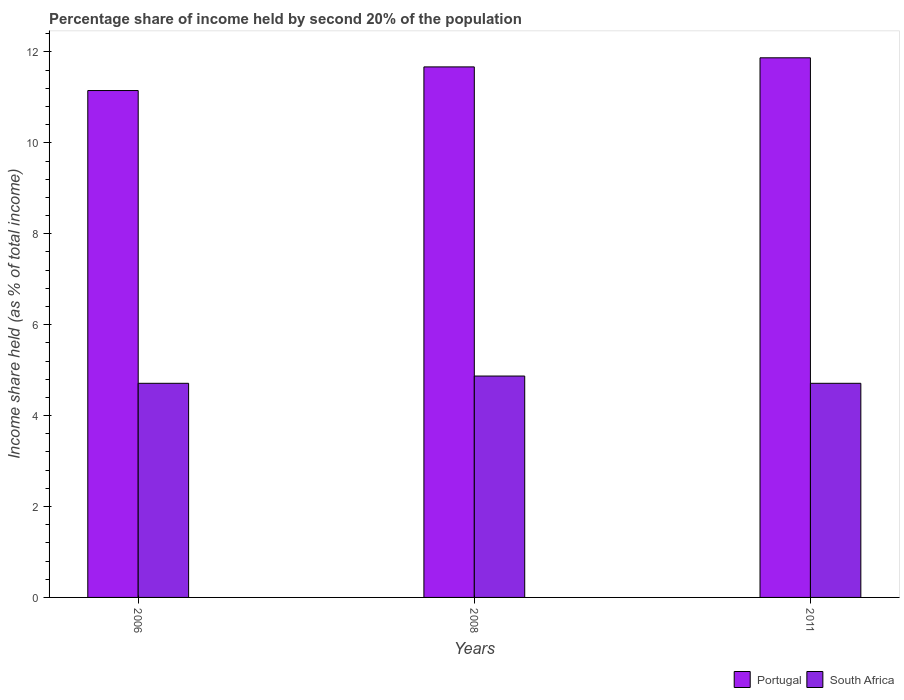How many different coloured bars are there?
Keep it short and to the point. 2. How many groups of bars are there?
Your response must be concise. 3. Are the number of bars per tick equal to the number of legend labels?
Your response must be concise. Yes. How many bars are there on the 3rd tick from the right?
Give a very brief answer. 2. In how many cases, is the number of bars for a given year not equal to the number of legend labels?
Offer a terse response. 0. What is the share of income held by second 20% of the population in South Africa in 2008?
Make the answer very short. 4.87. Across all years, what is the maximum share of income held by second 20% of the population in Portugal?
Your answer should be compact. 11.87. Across all years, what is the minimum share of income held by second 20% of the population in Portugal?
Give a very brief answer. 11.15. In which year was the share of income held by second 20% of the population in South Africa maximum?
Provide a succinct answer. 2008. What is the total share of income held by second 20% of the population in South Africa in the graph?
Offer a terse response. 14.29. What is the difference between the share of income held by second 20% of the population in South Africa in 2006 and that in 2008?
Give a very brief answer. -0.16. What is the difference between the share of income held by second 20% of the population in South Africa in 2008 and the share of income held by second 20% of the population in Portugal in 2011?
Provide a short and direct response. -7. What is the average share of income held by second 20% of the population in Portugal per year?
Offer a terse response. 11.56. In the year 2006, what is the difference between the share of income held by second 20% of the population in Portugal and share of income held by second 20% of the population in South Africa?
Your response must be concise. 6.44. In how many years, is the share of income held by second 20% of the population in Portugal greater than 3.2 %?
Ensure brevity in your answer.  3. What is the ratio of the share of income held by second 20% of the population in South Africa in 2006 to that in 2011?
Provide a short and direct response. 1. Is the share of income held by second 20% of the population in South Africa in 2008 less than that in 2011?
Your answer should be very brief. No. Is the difference between the share of income held by second 20% of the population in Portugal in 2006 and 2011 greater than the difference between the share of income held by second 20% of the population in South Africa in 2006 and 2011?
Give a very brief answer. No. What is the difference between the highest and the second highest share of income held by second 20% of the population in Portugal?
Offer a terse response. 0.2. What is the difference between the highest and the lowest share of income held by second 20% of the population in Portugal?
Give a very brief answer. 0.72. In how many years, is the share of income held by second 20% of the population in South Africa greater than the average share of income held by second 20% of the population in South Africa taken over all years?
Provide a succinct answer. 1. What does the 1st bar from the right in 2006 represents?
Provide a short and direct response. South Africa. Are all the bars in the graph horizontal?
Provide a short and direct response. No. Are the values on the major ticks of Y-axis written in scientific E-notation?
Your answer should be very brief. No. How many legend labels are there?
Your answer should be very brief. 2. How are the legend labels stacked?
Your answer should be compact. Horizontal. What is the title of the graph?
Make the answer very short. Percentage share of income held by second 20% of the population. What is the label or title of the X-axis?
Provide a short and direct response. Years. What is the label or title of the Y-axis?
Your answer should be compact. Income share held (as % of total income). What is the Income share held (as % of total income) in Portugal in 2006?
Give a very brief answer. 11.15. What is the Income share held (as % of total income) of South Africa in 2006?
Offer a very short reply. 4.71. What is the Income share held (as % of total income) of Portugal in 2008?
Ensure brevity in your answer.  11.67. What is the Income share held (as % of total income) of South Africa in 2008?
Make the answer very short. 4.87. What is the Income share held (as % of total income) in Portugal in 2011?
Offer a very short reply. 11.87. What is the Income share held (as % of total income) in South Africa in 2011?
Give a very brief answer. 4.71. Across all years, what is the maximum Income share held (as % of total income) of Portugal?
Your answer should be compact. 11.87. Across all years, what is the maximum Income share held (as % of total income) of South Africa?
Provide a succinct answer. 4.87. Across all years, what is the minimum Income share held (as % of total income) of Portugal?
Your response must be concise. 11.15. Across all years, what is the minimum Income share held (as % of total income) in South Africa?
Provide a short and direct response. 4.71. What is the total Income share held (as % of total income) in Portugal in the graph?
Offer a very short reply. 34.69. What is the total Income share held (as % of total income) in South Africa in the graph?
Make the answer very short. 14.29. What is the difference between the Income share held (as % of total income) of Portugal in 2006 and that in 2008?
Offer a terse response. -0.52. What is the difference between the Income share held (as % of total income) in South Africa in 2006 and that in 2008?
Your response must be concise. -0.16. What is the difference between the Income share held (as % of total income) of Portugal in 2006 and that in 2011?
Your answer should be very brief. -0.72. What is the difference between the Income share held (as % of total income) of South Africa in 2006 and that in 2011?
Ensure brevity in your answer.  0. What is the difference between the Income share held (as % of total income) in South Africa in 2008 and that in 2011?
Offer a terse response. 0.16. What is the difference between the Income share held (as % of total income) of Portugal in 2006 and the Income share held (as % of total income) of South Africa in 2008?
Your response must be concise. 6.28. What is the difference between the Income share held (as % of total income) in Portugal in 2006 and the Income share held (as % of total income) in South Africa in 2011?
Keep it short and to the point. 6.44. What is the difference between the Income share held (as % of total income) of Portugal in 2008 and the Income share held (as % of total income) of South Africa in 2011?
Offer a terse response. 6.96. What is the average Income share held (as % of total income) of Portugal per year?
Keep it short and to the point. 11.56. What is the average Income share held (as % of total income) in South Africa per year?
Make the answer very short. 4.76. In the year 2006, what is the difference between the Income share held (as % of total income) in Portugal and Income share held (as % of total income) in South Africa?
Your answer should be very brief. 6.44. In the year 2008, what is the difference between the Income share held (as % of total income) of Portugal and Income share held (as % of total income) of South Africa?
Keep it short and to the point. 6.8. In the year 2011, what is the difference between the Income share held (as % of total income) of Portugal and Income share held (as % of total income) of South Africa?
Offer a very short reply. 7.16. What is the ratio of the Income share held (as % of total income) of Portugal in 2006 to that in 2008?
Offer a terse response. 0.96. What is the ratio of the Income share held (as % of total income) in South Africa in 2006 to that in 2008?
Provide a short and direct response. 0.97. What is the ratio of the Income share held (as % of total income) of Portugal in 2006 to that in 2011?
Provide a short and direct response. 0.94. What is the ratio of the Income share held (as % of total income) in South Africa in 2006 to that in 2011?
Offer a terse response. 1. What is the ratio of the Income share held (as % of total income) of Portugal in 2008 to that in 2011?
Keep it short and to the point. 0.98. What is the ratio of the Income share held (as % of total income) of South Africa in 2008 to that in 2011?
Your answer should be compact. 1.03. What is the difference between the highest and the second highest Income share held (as % of total income) in South Africa?
Ensure brevity in your answer.  0.16. What is the difference between the highest and the lowest Income share held (as % of total income) in Portugal?
Offer a terse response. 0.72. What is the difference between the highest and the lowest Income share held (as % of total income) in South Africa?
Your answer should be compact. 0.16. 